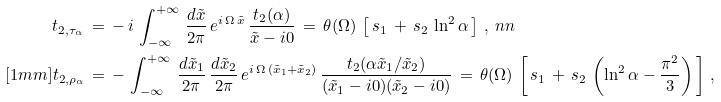<formula> <loc_0><loc_0><loc_500><loc_500>t _ { 2 , \tau _ { \alpha } } \, & = \, - \, i \, \int _ { - \infty } ^ { + \infty } \, \frac { d \tilde { x } } { 2 \pi } \, e ^ { i \, \Omega \, \tilde { x } } \, \frac { t _ { 2 } ( \alpha ) } { \tilde { x } - i 0 } \, = \, \theta ( \Omega ) \, \left [ \, s _ { 1 } \, + \, s _ { 2 } \, \ln ^ { 2 } \alpha \, \right ] \, , \ n n \\ [ 1 m m ] t _ { 2 , \rho _ { \alpha } } \, & = \, - \, \int _ { - \infty } ^ { + \infty } \, \frac { d \tilde { x } _ { 1 } } { 2 \pi } \, \frac { d \tilde { x } _ { 2 } } { 2 \pi } \, e ^ { i \, \Omega \, ( \tilde { x } _ { 1 } + \tilde { x } _ { 2 } ) } \, \frac { t _ { 2 } ( \alpha \tilde { x } _ { 1 } / \tilde { x } _ { 2 } ) } { ( \tilde { x } _ { 1 } - i 0 ) ( \tilde { x } _ { 2 } - i 0 ) } \, = \, \theta ( \Omega ) \, \left [ \, s _ { 1 } \, + \, s _ { 2 } \, \left ( \ln ^ { 2 } \alpha - \frac { \pi ^ { 2 } } { 3 } \right ) \, \right ] \, ,</formula> 